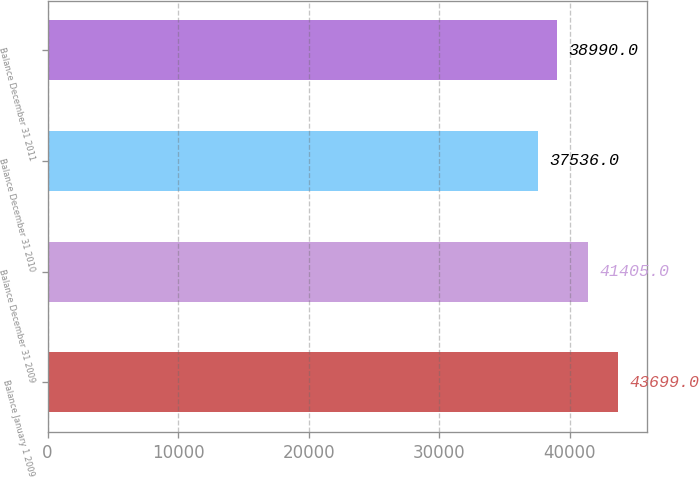Convert chart to OTSL. <chart><loc_0><loc_0><loc_500><loc_500><bar_chart><fcel>Balance January 1 2009<fcel>Balance December 31 2009<fcel>Balance December 31 2010<fcel>Balance December 31 2011<nl><fcel>43699<fcel>41405<fcel>37536<fcel>38990<nl></chart> 